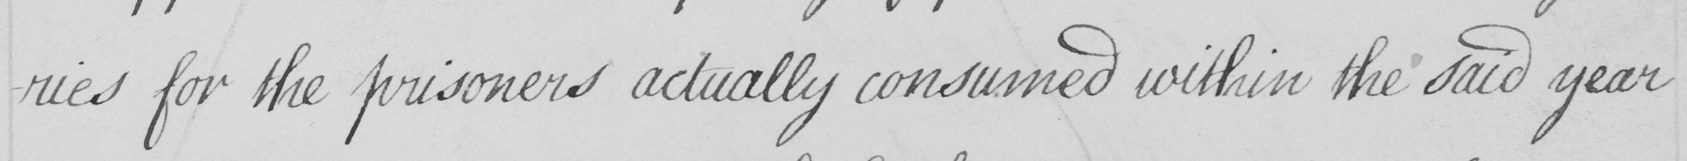Can you tell me what this handwritten text says? -ries for the prisoners actually consumed within the said year 